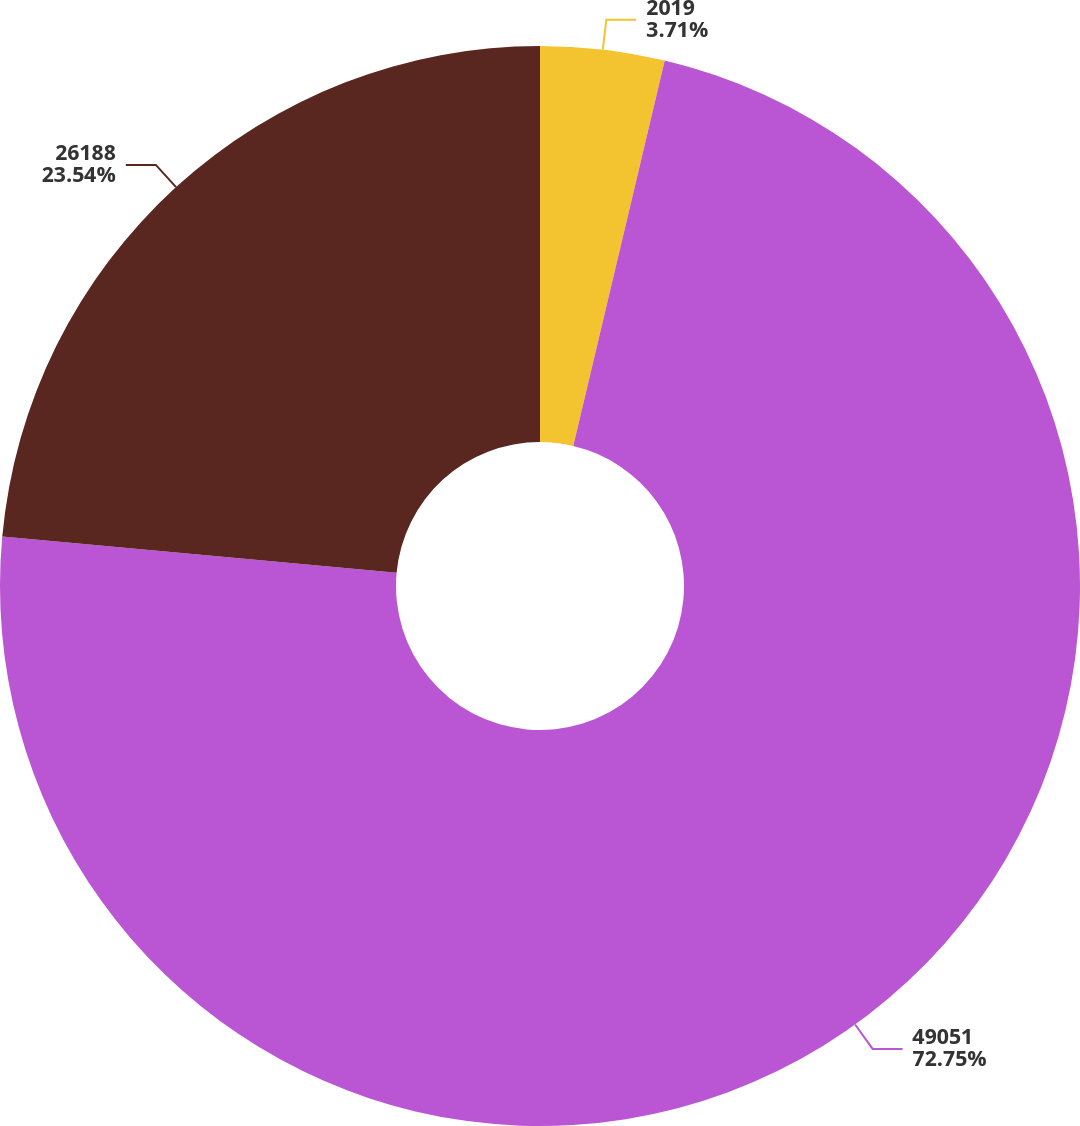Convert chart. <chart><loc_0><loc_0><loc_500><loc_500><pie_chart><fcel>2019<fcel>49051<fcel>26188<nl><fcel>3.71%<fcel>72.74%<fcel>23.54%<nl></chart> 